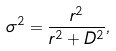Convert formula to latex. <formula><loc_0><loc_0><loc_500><loc_500>\sigma ^ { 2 } = \frac { r ^ { 2 } } { r ^ { 2 } + D ^ { 2 } } ,</formula> 